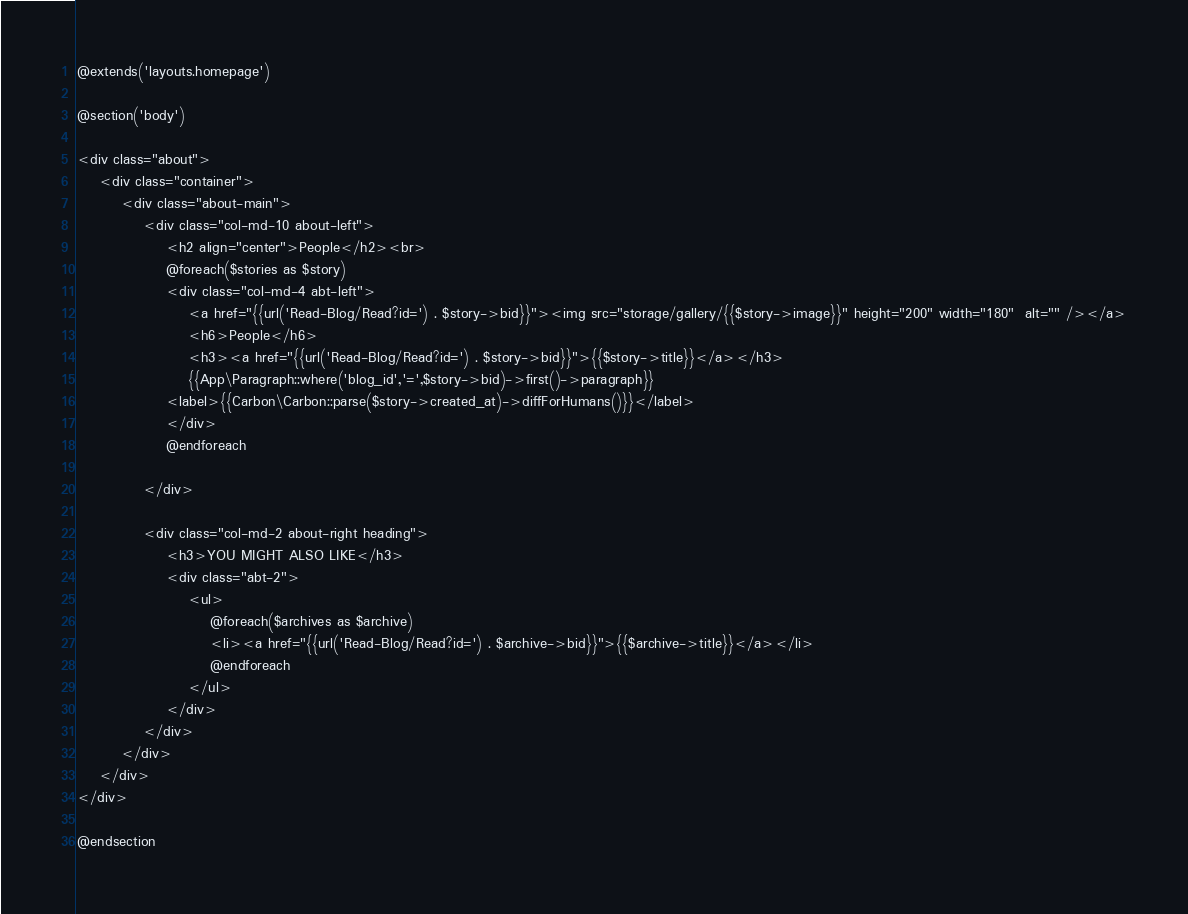Convert code to text. <code><loc_0><loc_0><loc_500><loc_500><_PHP_>@extends('layouts.homepage')

@section('body')

<div class="about">
	<div class="container">
		<div class="about-main">
			<div class="col-md-10 about-left">
				<h2 align="center">People</h2><br>
				@foreach($stories as $story)
				<div class="col-md-4 abt-left">
					<a href="{{url('Read-Blog/Read?id=') . $story->bid}}"><img src="storage/gallery/{{$story->image}}" height="200" width="180"  alt="" /></a>
					<h6>People</h6>
					<h3><a href="{{url('Read-Blog/Read?id=') . $story->bid}}">{{$story->title}}</a></h3>
					{{App\Paragraph::where('blog_id','=',$story->bid)->first()->paragraph}}					
				<label>{{Carbon\Carbon::parse($story->created_at)->diffForHumans()}}</label>
				</div>
				@endforeach		

			</div>

			<div class="col-md-2 about-right heading">
				<h3>YOU MIGHT ALSO LIKE</h3>
				<div class="abt-2">
					<ul>
						@foreach($archives as $archive)
						<li><a href="{{url('Read-Blog/Read?id=') . $archive->bid}}">{{$archive->title}}</a></li>
						@endforeach
					</ul>	
				</div>
			</div>
		</div>
	</div>
</div>

@endsection</code> 